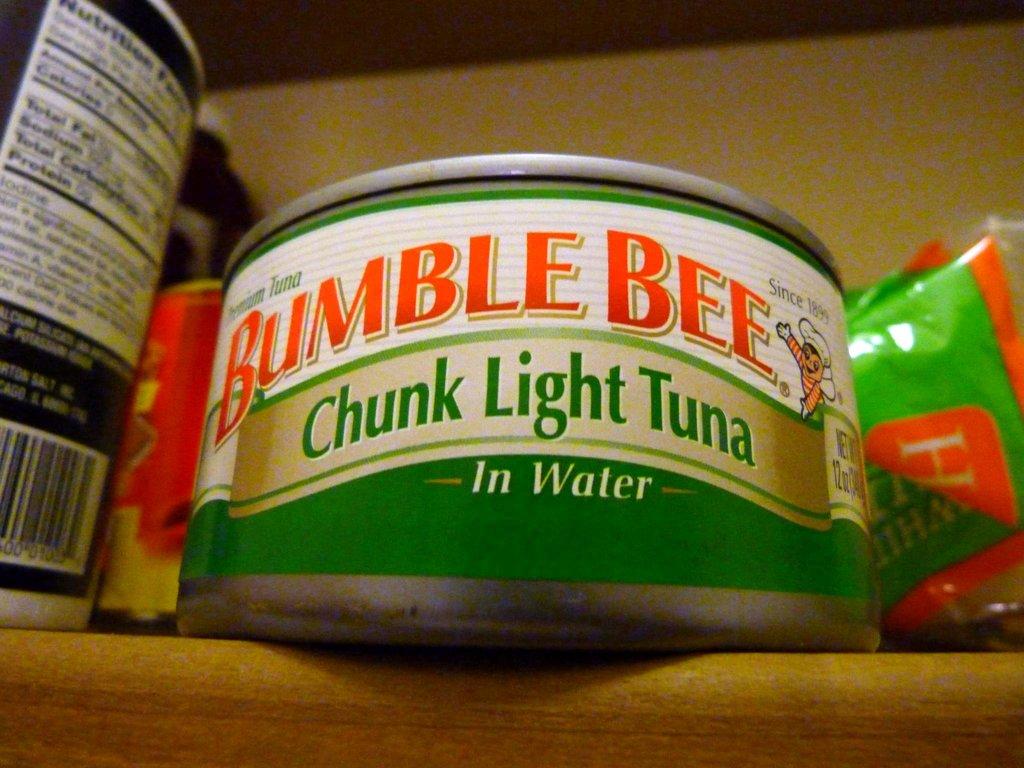Is the tuna in oil or in water?
Offer a terse response. Water. Is the tuna light or not?
Offer a very short reply. Light. 